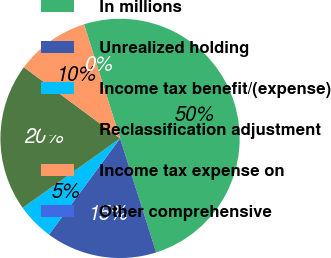Convert chart. <chart><loc_0><loc_0><loc_500><loc_500><pie_chart><fcel>In millions<fcel>Unrealized holding<fcel>Income tax benefit/(expense)<fcel>Reclassification adjustment<fcel>Income tax expense on<fcel>Other comprehensive<nl><fcel>49.98%<fcel>15.0%<fcel>5.01%<fcel>20.0%<fcel>10.0%<fcel>0.01%<nl></chart> 